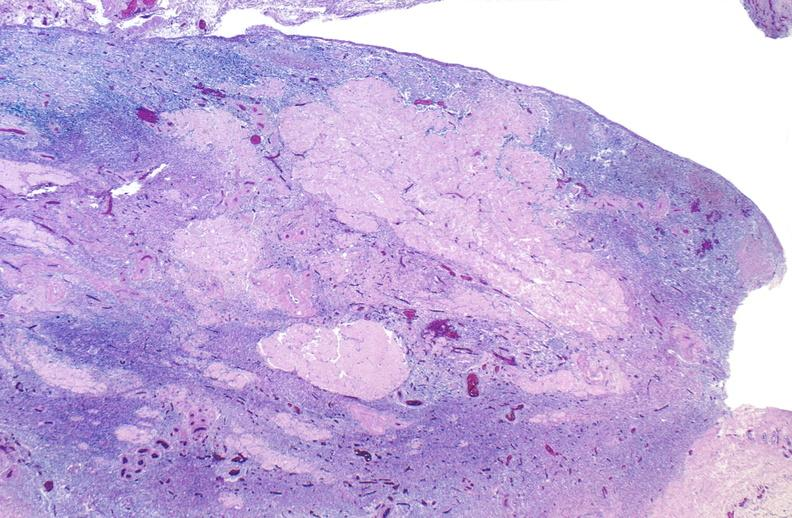does nodule show normal ovary?
Answer the question using a single word or phrase. No 